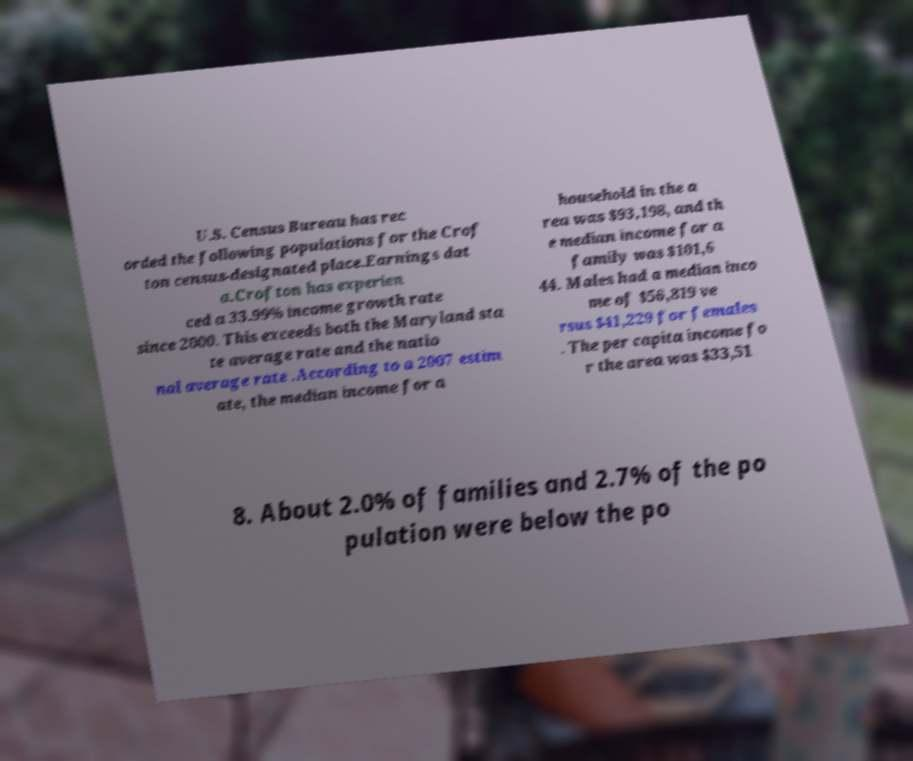Could you assist in decoding the text presented in this image and type it out clearly? U.S. Census Bureau has rec orded the following populations for the Crof ton census-designated place.Earnings dat a.Crofton has experien ced a 33.99% income growth rate since 2000. This exceeds both the Maryland sta te average rate and the natio nal average rate .According to a 2007 estim ate, the median income for a household in the a rea was $93,198, and th e median income for a family was $101,6 44. Males had a median inco me of $56,819 ve rsus $41,229 for females . The per capita income fo r the area was $33,51 8. About 2.0% of families and 2.7% of the po pulation were below the po 